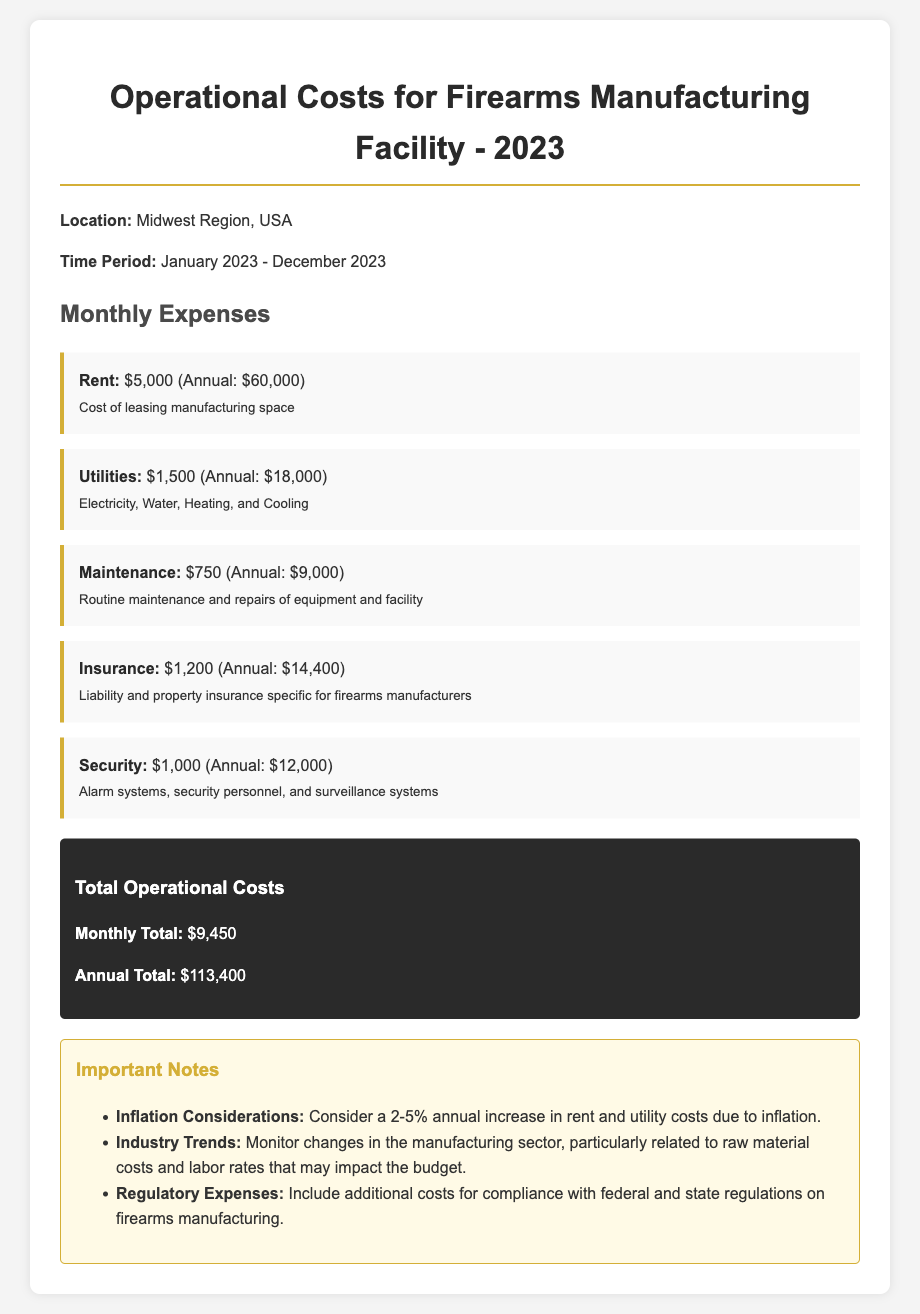What is the total monthly rent expense? The total monthly rent expense is specified in the document as $5,000.
Answer: $5,000 What are the annual maintenance costs? The annual maintenance costs are derived from the monthly maintenance expense of $750 multiplied by 12 months, which totals $9,000.
Answer: $9,000 How much is spent monthly on utilities? The document states that the monthly expenses for utilities amount to $1,500.
Answer: $1,500 What is the total annual operational cost? The total annual operational cost is the sum of the monthly totals multiplied by 12, which equals $113,400.
Answer: $113,400 How much does the facility spend on insurance each month? The monthly insurance cost is provided in the document as $1,200.
Answer: $1,200 What category has the highest monthly expenses? Given the details, the highest monthly expense is for rent at $5,000.
Answer: Rent What is the total monthly expense for security? The document indicates that the monthly expense for security is $1,000.
Answer: $1,000 What factors may increase the operational costs? The document mentions inflation as a factor that may increase costs by 2-5% annually.
Answer: Inflation What is the monthly total for maintenance and utilities combined? The monthly total for maintenance ($750) and utilities ($1,500) is calculated as $2,250.
Answer: $2,250 